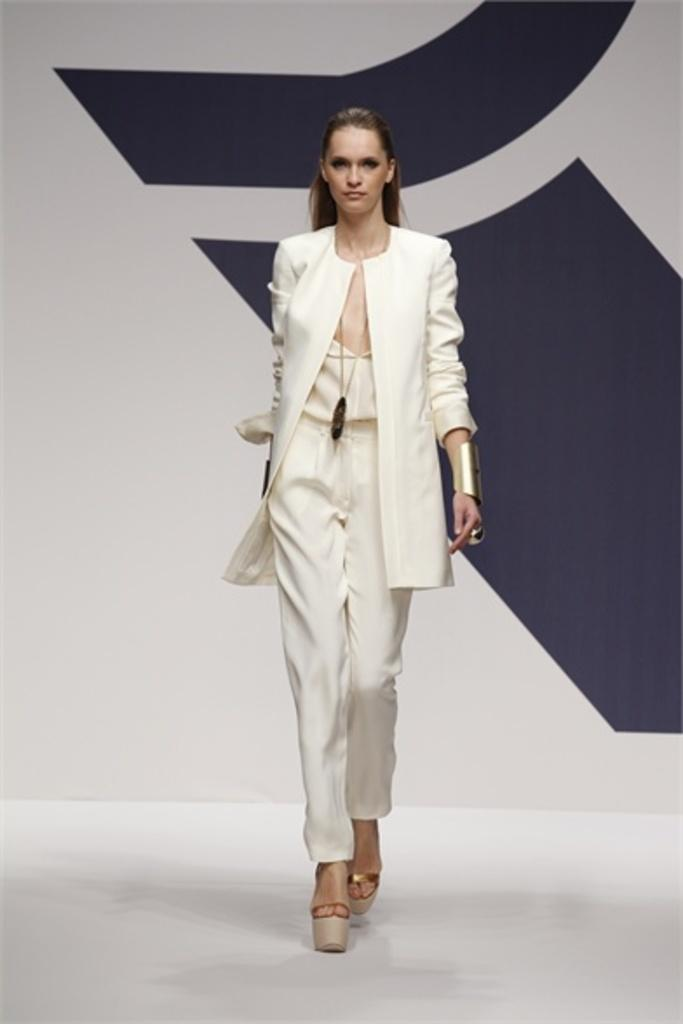Who is the main subject in the image? There is a woman in the image. What is the woman doing in the image? The woman is walking on the floor. Can you describe the background of the image? The background of the image includes black and white colors. What type of minister is present in the image? There is no minister present in the image; it features a woman walking on the floor. What type of dinner is being served in the image? There is no dinner present in the image; it only shows a woman walking on the floor with a black and white background. 